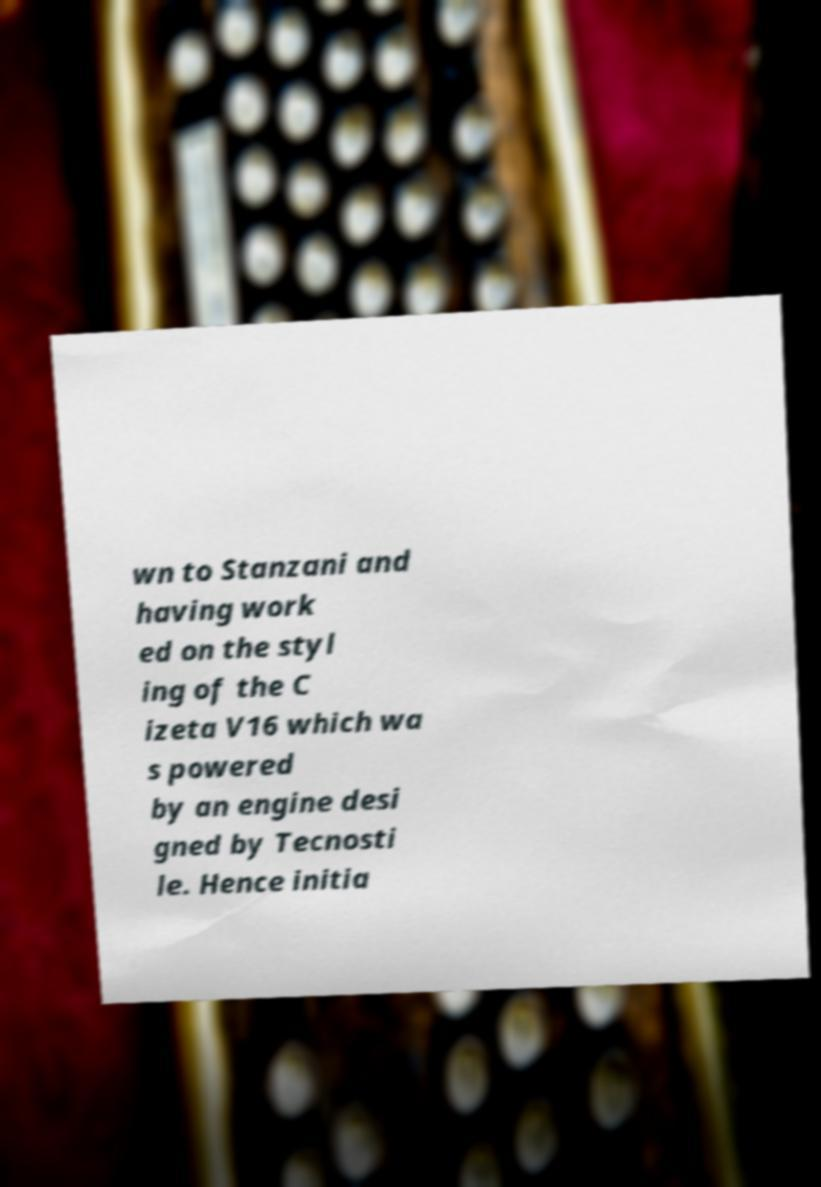Could you extract and type out the text from this image? wn to Stanzani and having work ed on the styl ing of the C izeta V16 which wa s powered by an engine desi gned by Tecnosti le. Hence initia 